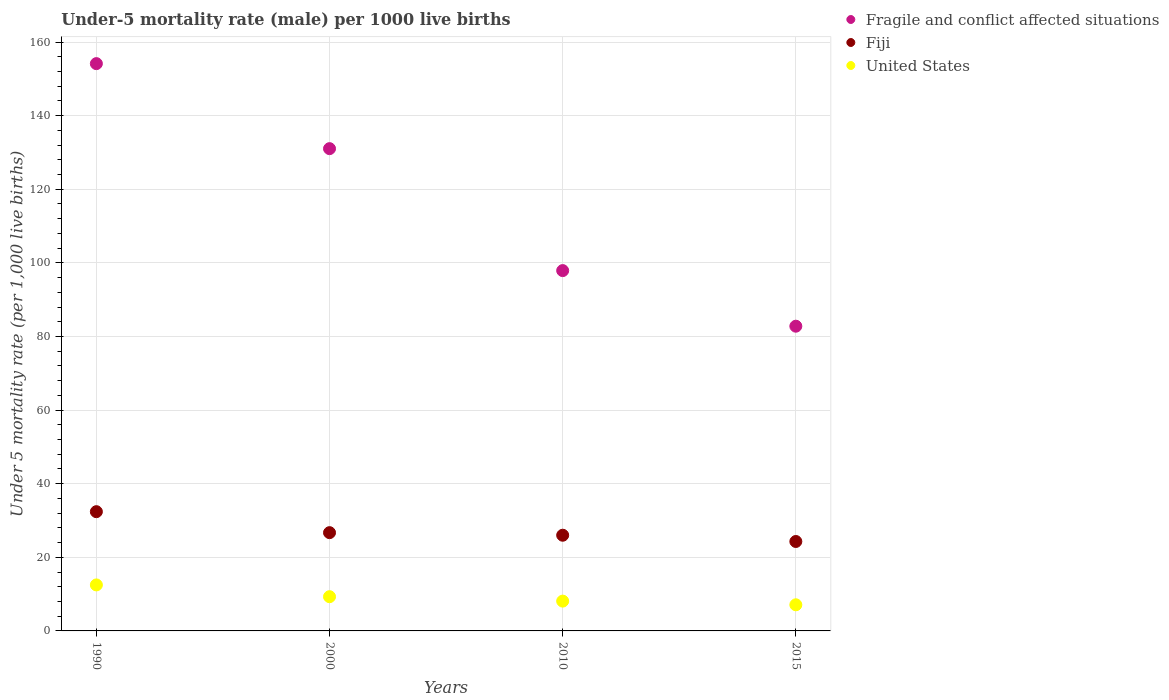How many different coloured dotlines are there?
Your response must be concise. 3. What is the under-five mortality rate in Fragile and conflict affected situations in 2010?
Ensure brevity in your answer.  97.9. Across all years, what is the maximum under-five mortality rate in Fragile and conflict affected situations?
Your response must be concise. 154.14. Across all years, what is the minimum under-five mortality rate in United States?
Offer a very short reply. 7.1. In which year was the under-five mortality rate in Fiji maximum?
Your response must be concise. 1990. In which year was the under-five mortality rate in United States minimum?
Your answer should be very brief. 2015. What is the total under-five mortality rate in Fragile and conflict affected situations in the graph?
Keep it short and to the point. 465.87. What is the difference between the under-five mortality rate in Fragile and conflict affected situations in 2010 and that in 2015?
Make the answer very short. 15.11. What is the difference between the under-five mortality rate in United States in 2000 and the under-five mortality rate in Fragile and conflict affected situations in 1990?
Offer a terse response. -144.84. What is the average under-five mortality rate in Fiji per year?
Offer a terse response. 27.35. In the year 2000, what is the difference between the under-five mortality rate in Fiji and under-five mortality rate in United States?
Provide a succinct answer. 17.4. In how many years, is the under-five mortality rate in Fragile and conflict affected situations greater than 132?
Provide a succinct answer. 1. What is the ratio of the under-five mortality rate in Fragile and conflict affected situations in 2010 to that in 2015?
Keep it short and to the point. 1.18. What is the difference between the highest and the second highest under-five mortality rate in Fragile and conflict affected situations?
Your answer should be very brief. 23.1. What is the difference between the highest and the lowest under-five mortality rate in Fiji?
Offer a very short reply. 8.1. Is the sum of the under-five mortality rate in United States in 2000 and 2015 greater than the maximum under-five mortality rate in Fragile and conflict affected situations across all years?
Provide a succinct answer. No. Is the under-five mortality rate in Fragile and conflict affected situations strictly greater than the under-five mortality rate in Fiji over the years?
Give a very brief answer. Yes. What is the difference between two consecutive major ticks on the Y-axis?
Your response must be concise. 20. Are the values on the major ticks of Y-axis written in scientific E-notation?
Give a very brief answer. No. Does the graph contain any zero values?
Make the answer very short. No. Where does the legend appear in the graph?
Make the answer very short. Top right. How are the legend labels stacked?
Provide a succinct answer. Vertical. What is the title of the graph?
Offer a terse response. Under-5 mortality rate (male) per 1000 live births. What is the label or title of the Y-axis?
Your answer should be very brief. Under 5 mortality rate (per 1,0 live births). What is the Under 5 mortality rate (per 1,000 live births) of Fragile and conflict affected situations in 1990?
Keep it short and to the point. 154.14. What is the Under 5 mortality rate (per 1,000 live births) in Fiji in 1990?
Give a very brief answer. 32.4. What is the Under 5 mortality rate (per 1,000 live births) in United States in 1990?
Provide a succinct answer. 12.5. What is the Under 5 mortality rate (per 1,000 live births) of Fragile and conflict affected situations in 2000?
Offer a very short reply. 131.04. What is the Under 5 mortality rate (per 1,000 live births) of Fiji in 2000?
Provide a short and direct response. 26.7. What is the Under 5 mortality rate (per 1,000 live births) in United States in 2000?
Your answer should be compact. 9.3. What is the Under 5 mortality rate (per 1,000 live births) of Fragile and conflict affected situations in 2010?
Keep it short and to the point. 97.9. What is the Under 5 mortality rate (per 1,000 live births) of United States in 2010?
Your answer should be very brief. 8.1. What is the Under 5 mortality rate (per 1,000 live births) of Fragile and conflict affected situations in 2015?
Ensure brevity in your answer.  82.79. What is the Under 5 mortality rate (per 1,000 live births) of Fiji in 2015?
Provide a succinct answer. 24.3. What is the Under 5 mortality rate (per 1,000 live births) in United States in 2015?
Offer a terse response. 7.1. Across all years, what is the maximum Under 5 mortality rate (per 1,000 live births) of Fragile and conflict affected situations?
Keep it short and to the point. 154.14. Across all years, what is the maximum Under 5 mortality rate (per 1,000 live births) in Fiji?
Your response must be concise. 32.4. Across all years, what is the minimum Under 5 mortality rate (per 1,000 live births) of Fragile and conflict affected situations?
Offer a terse response. 82.79. Across all years, what is the minimum Under 5 mortality rate (per 1,000 live births) in Fiji?
Offer a terse response. 24.3. What is the total Under 5 mortality rate (per 1,000 live births) of Fragile and conflict affected situations in the graph?
Give a very brief answer. 465.87. What is the total Under 5 mortality rate (per 1,000 live births) in Fiji in the graph?
Give a very brief answer. 109.4. What is the difference between the Under 5 mortality rate (per 1,000 live births) of Fragile and conflict affected situations in 1990 and that in 2000?
Ensure brevity in your answer.  23.1. What is the difference between the Under 5 mortality rate (per 1,000 live births) in United States in 1990 and that in 2000?
Ensure brevity in your answer.  3.2. What is the difference between the Under 5 mortality rate (per 1,000 live births) in Fragile and conflict affected situations in 1990 and that in 2010?
Provide a short and direct response. 56.23. What is the difference between the Under 5 mortality rate (per 1,000 live births) of Fragile and conflict affected situations in 1990 and that in 2015?
Offer a very short reply. 71.34. What is the difference between the Under 5 mortality rate (per 1,000 live births) in Fiji in 1990 and that in 2015?
Your answer should be compact. 8.1. What is the difference between the Under 5 mortality rate (per 1,000 live births) in Fragile and conflict affected situations in 2000 and that in 2010?
Your answer should be very brief. 33.13. What is the difference between the Under 5 mortality rate (per 1,000 live births) in United States in 2000 and that in 2010?
Provide a short and direct response. 1.2. What is the difference between the Under 5 mortality rate (per 1,000 live births) of Fragile and conflict affected situations in 2000 and that in 2015?
Your response must be concise. 48.24. What is the difference between the Under 5 mortality rate (per 1,000 live births) of Fiji in 2000 and that in 2015?
Give a very brief answer. 2.4. What is the difference between the Under 5 mortality rate (per 1,000 live births) of Fragile and conflict affected situations in 2010 and that in 2015?
Your answer should be compact. 15.11. What is the difference between the Under 5 mortality rate (per 1,000 live births) of Fiji in 2010 and that in 2015?
Your answer should be very brief. 1.7. What is the difference between the Under 5 mortality rate (per 1,000 live births) of United States in 2010 and that in 2015?
Keep it short and to the point. 1. What is the difference between the Under 5 mortality rate (per 1,000 live births) in Fragile and conflict affected situations in 1990 and the Under 5 mortality rate (per 1,000 live births) in Fiji in 2000?
Offer a terse response. 127.44. What is the difference between the Under 5 mortality rate (per 1,000 live births) of Fragile and conflict affected situations in 1990 and the Under 5 mortality rate (per 1,000 live births) of United States in 2000?
Make the answer very short. 144.84. What is the difference between the Under 5 mortality rate (per 1,000 live births) in Fiji in 1990 and the Under 5 mortality rate (per 1,000 live births) in United States in 2000?
Make the answer very short. 23.1. What is the difference between the Under 5 mortality rate (per 1,000 live births) in Fragile and conflict affected situations in 1990 and the Under 5 mortality rate (per 1,000 live births) in Fiji in 2010?
Your answer should be very brief. 128.14. What is the difference between the Under 5 mortality rate (per 1,000 live births) in Fragile and conflict affected situations in 1990 and the Under 5 mortality rate (per 1,000 live births) in United States in 2010?
Ensure brevity in your answer.  146.04. What is the difference between the Under 5 mortality rate (per 1,000 live births) of Fiji in 1990 and the Under 5 mortality rate (per 1,000 live births) of United States in 2010?
Offer a terse response. 24.3. What is the difference between the Under 5 mortality rate (per 1,000 live births) in Fragile and conflict affected situations in 1990 and the Under 5 mortality rate (per 1,000 live births) in Fiji in 2015?
Offer a very short reply. 129.84. What is the difference between the Under 5 mortality rate (per 1,000 live births) in Fragile and conflict affected situations in 1990 and the Under 5 mortality rate (per 1,000 live births) in United States in 2015?
Offer a very short reply. 147.04. What is the difference between the Under 5 mortality rate (per 1,000 live births) in Fiji in 1990 and the Under 5 mortality rate (per 1,000 live births) in United States in 2015?
Keep it short and to the point. 25.3. What is the difference between the Under 5 mortality rate (per 1,000 live births) in Fragile and conflict affected situations in 2000 and the Under 5 mortality rate (per 1,000 live births) in Fiji in 2010?
Give a very brief answer. 105.04. What is the difference between the Under 5 mortality rate (per 1,000 live births) in Fragile and conflict affected situations in 2000 and the Under 5 mortality rate (per 1,000 live births) in United States in 2010?
Offer a very short reply. 122.94. What is the difference between the Under 5 mortality rate (per 1,000 live births) of Fragile and conflict affected situations in 2000 and the Under 5 mortality rate (per 1,000 live births) of Fiji in 2015?
Offer a very short reply. 106.74. What is the difference between the Under 5 mortality rate (per 1,000 live births) in Fragile and conflict affected situations in 2000 and the Under 5 mortality rate (per 1,000 live births) in United States in 2015?
Offer a terse response. 123.94. What is the difference between the Under 5 mortality rate (per 1,000 live births) in Fiji in 2000 and the Under 5 mortality rate (per 1,000 live births) in United States in 2015?
Provide a short and direct response. 19.6. What is the difference between the Under 5 mortality rate (per 1,000 live births) of Fragile and conflict affected situations in 2010 and the Under 5 mortality rate (per 1,000 live births) of Fiji in 2015?
Ensure brevity in your answer.  73.6. What is the difference between the Under 5 mortality rate (per 1,000 live births) of Fragile and conflict affected situations in 2010 and the Under 5 mortality rate (per 1,000 live births) of United States in 2015?
Your answer should be very brief. 90.8. What is the average Under 5 mortality rate (per 1,000 live births) of Fragile and conflict affected situations per year?
Make the answer very short. 116.47. What is the average Under 5 mortality rate (per 1,000 live births) of Fiji per year?
Give a very brief answer. 27.35. What is the average Under 5 mortality rate (per 1,000 live births) of United States per year?
Offer a very short reply. 9.25. In the year 1990, what is the difference between the Under 5 mortality rate (per 1,000 live births) in Fragile and conflict affected situations and Under 5 mortality rate (per 1,000 live births) in Fiji?
Ensure brevity in your answer.  121.74. In the year 1990, what is the difference between the Under 5 mortality rate (per 1,000 live births) in Fragile and conflict affected situations and Under 5 mortality rate (per 1,000 live births) in United States?
Ensure brevity in your answer.  141.64. In the year 1990, what is the difference between the Under 5 mortality rate (per 1,000 live births) of Fiji and Under 5 mortality rate (per 1,000 live births) of United States?
Provide a succinct answer. 19.9. In the year 2000, what is the difference between the Under 5 mortality rate (per 1,000 live births) of Fragile and conflict affected situations and Under 5 mortality rate (per 1,000 live births) of Fiji?
Provide a succinct answer. 104.34. In the year 2000, what is the difference between the Under 5 mortality rate (per 1,000 live births) in Fragile and conflict affected situations and Under 5 mortality rate (per 1,000 live births) in United States?
Provide a short and direct response. 121.74. In the year 2010, what is the difference between the Under 5 mortality rate (per 1,000 live births) in Fragile and conflict affected situations and Under 5 mortality rate (per 1,000 live births) in Fiji?
Offer a terse response. 71.9. In the year 2010, what is the difference between the Under 5 mortality rate (per 1,000 live births) in Fragile and conflict affected situations and Under 5 mortality rate (per 1,000 live births) in United States?
Offer a very short reply. 89.8. In the year 2010, what is the difference between the Under 5 mortality rate (per 1,000 live births) in Fiji and Under 5 mortality rate (per 1,000 live births) in United States?
Provide a succinct answer. 17.9. In the year 2015, what is the difference between the Under 5 mortality rate (per 1,000 live births) in Fragile and conflict affected situations and Under 5 mortality rate (per 1,000 live births) in Fiji?
Give a very brief answer. 58.49. In the year 2015, what is the difference between the Under 5 mortality rate (per 1,000 live births) in Fragile and conflict affected situations and Under 5 mortality rate (per 1,000 live births) in United States?
Your response must be concise. 75.69. What is the ratio of the Under 5 mortality rate (per 1,000 live births) of Fragile and conflict affected situations in 1990 to that in 2000?
Provide a succinct answer. 1.18. What is the ratio of the Under 5 mortality rate (per 1,000 live births) of Fiji in 1990 to that in 2000?
Your answer should be very brief. 1.21. What is the ratio of the Under 5 mortality rate (per 1,000 live births) in United States in 1990 to that in 2000?
Make the answer very short. 1.34. What is the ratio of the Under 5 mortality rate (per 1,000 live births) of Fragile and conflict affected situations in 1990 to that in 2010?
Give a very brief answer. 1.57. What is the ratio of the Under 5 mortality rate (per 1,000 live births) of Fiji in 1990 to that in 2010?
Your response must be concise. 1.25. What is the ratio of the Under 5 mortality rate (per 1,000 live births) in United States in 1990 to that in 2010?
Keep it short and to the point. 1.54. What is the ratio of the Under 5 mortality rate (per 1,000 live births) in Fragile and conflict affected situations in 1990 to that in 2015?
Provide a succinct answer. 1.86. What is the ratio of the Under 5 mortality rate (per 1,000 live births) in United States in 1990 to that in 2015?
Give a very brief answer. 1.76. What is the ratio of the Under 5 mortality rate (per 1,000 live births) in Fragile and conflict affected situations in 2000 to that in 2010?
Make the answer very short. 1.34. What is the ratio of the Under 5 mortality rate (per 1,000 live births) of Fiji in 2000 to that in 2010?
Keep it short and to the point. 1.03. What is the ratio of the Under 5 mortality rate (per 1,000 live births) in United States in 2000 to that in 2010?
Give a very brief answer. 1.15. What is the ratio of the Under 5 mortality rate (per 1,000 live births) of Fragile and conflict affected situations in 2000 to that in 2015?
Your answer should be compact. 1.58. What is the ratio of the Under 5 mortality rate (per 1,000 live births) of Fiji in 2000 to that in 2015?
Offer a terse response. 1.1. What is the ratio of the Under 5 mortality rate (per 1,000 live births) of United States in 2000 to that in 2015?
Offer a terse response. 1.31. What is the ratio of the Under 5 mortality rate (per 1,000 live births) in Fragile and conflict affected situations in 2010 to that in 2015?
Offer a very short reply. 1.18. What is the ratio of the Under 5 mortality rate (per 1,000 live births) of Fiji in 2010 to that in 2015?
Ensure brevity in your answer.  1.07. What is the ratio of the Under 5 mortality rate (per 1,000 live births) in United States in 2010 to that in 2015?
Provide a succinct answer. 1.14. What is the difference between the highest and the second highest Under 5 mortality rate (per 1,000 live births) in Fragile and conflict affected situations?
Give a very brief answer. 23.1. What is the difference between the highest and the second highest Under 5 mortality rate (per 1,000 live births) in United States?
Provide a succinct answer. 3.2. What is the difference between the highest and the lowest Under 5 mortality rate (per 1,000 live births) of Fragile and conflict affected situations?
Offer a very short reply. 71.34. What is the difference between the highest and the lowest Under 5 mortality rate (per 1,000 live births) in Fiji?
Provide a succinct answer. 8.1. What is the difference between the highest and the lowest Under 5 mortality rate (per 1,000 live births) of United States?
Offer a very short reply. 5.4. 